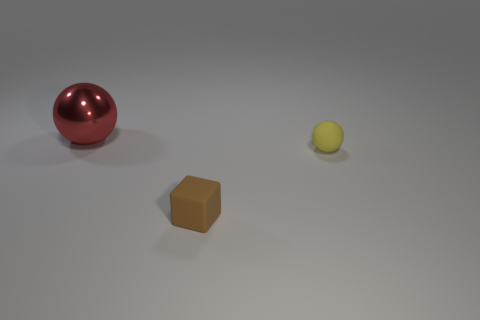Add 1 rubber blocks. How many objects exist? 4 Subtract all cubes. How many objects are left? 2 Subtract all small matte cubes. Subtract all brown things. How many objects are left? 1 Add 2 large objects. How many large objects are left? 3 Add 1 tiny green rubber cylinders. How many tiny green rubber cylinders exist? 1 Subtract 1 red spheres. How many objects are left? 2 